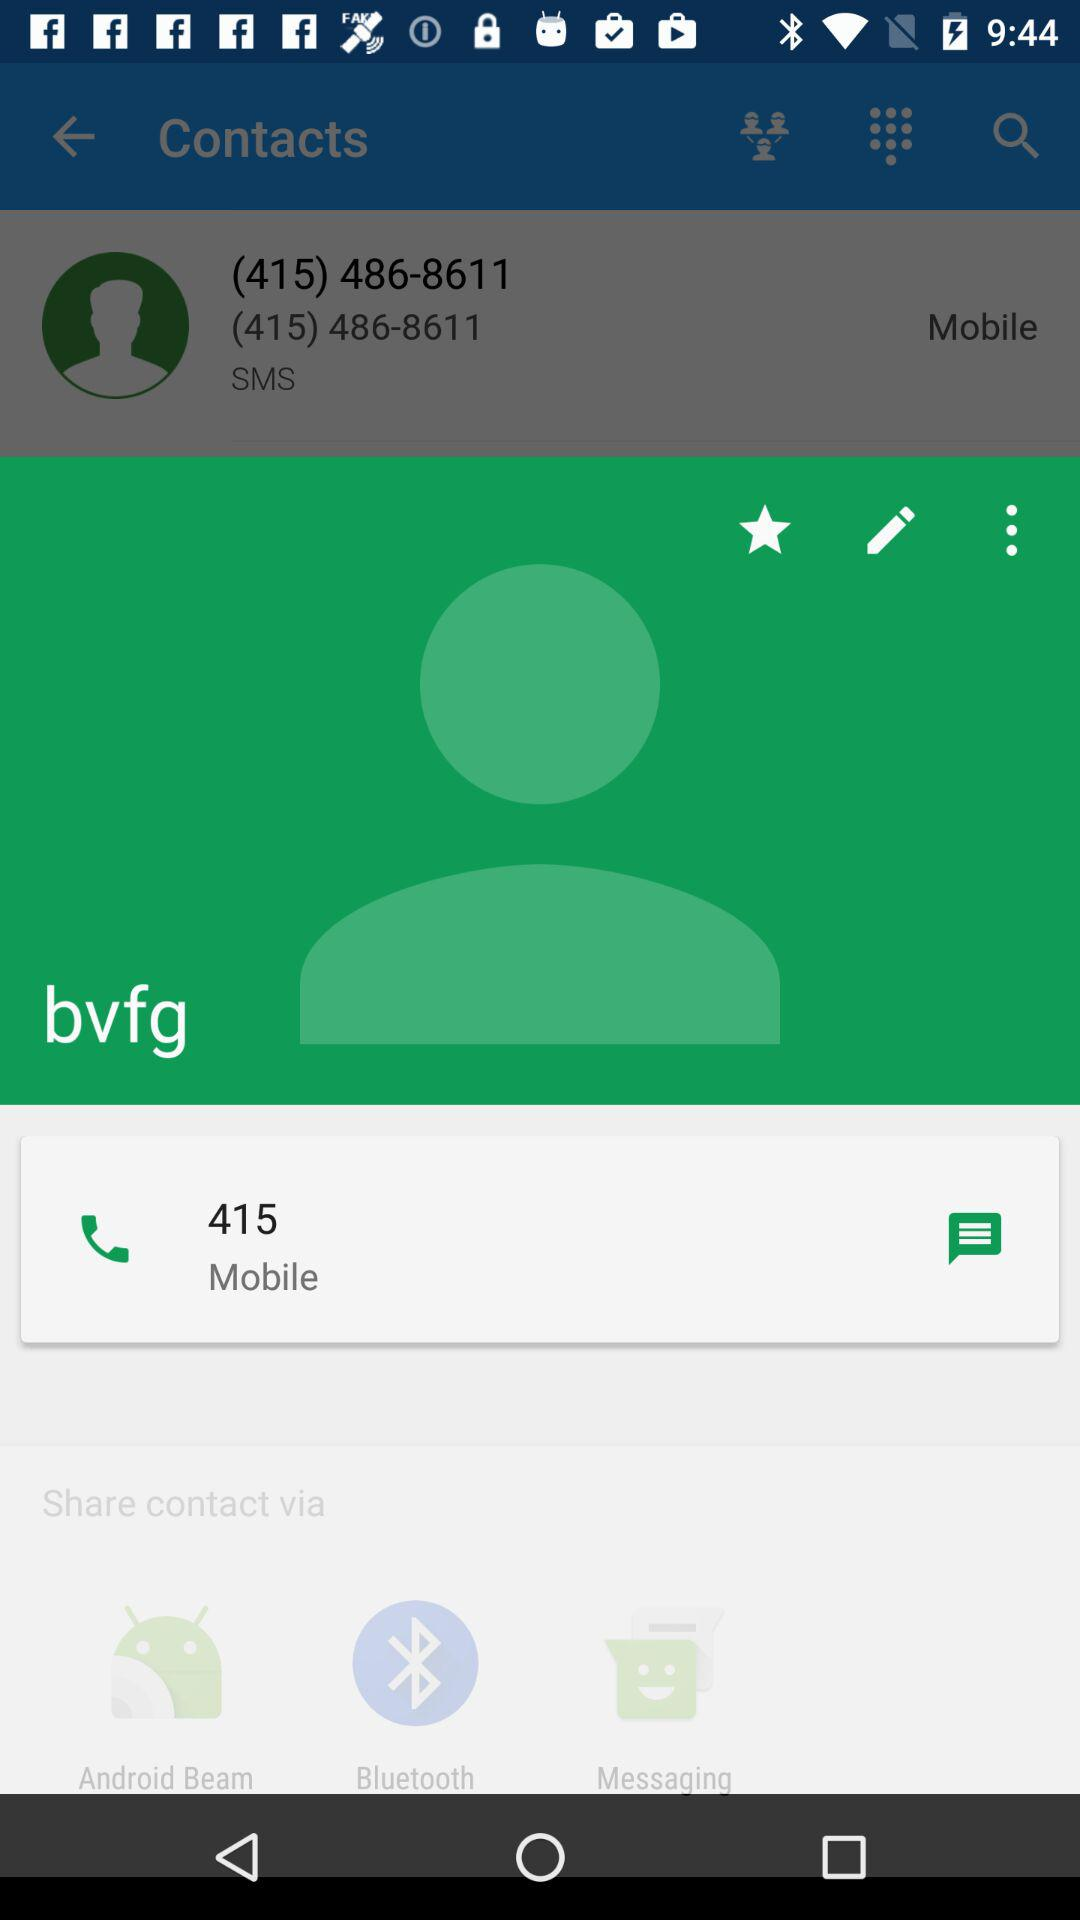What is the mobile number for "bvfg"? The mobile number for "bvfg" is 415. 